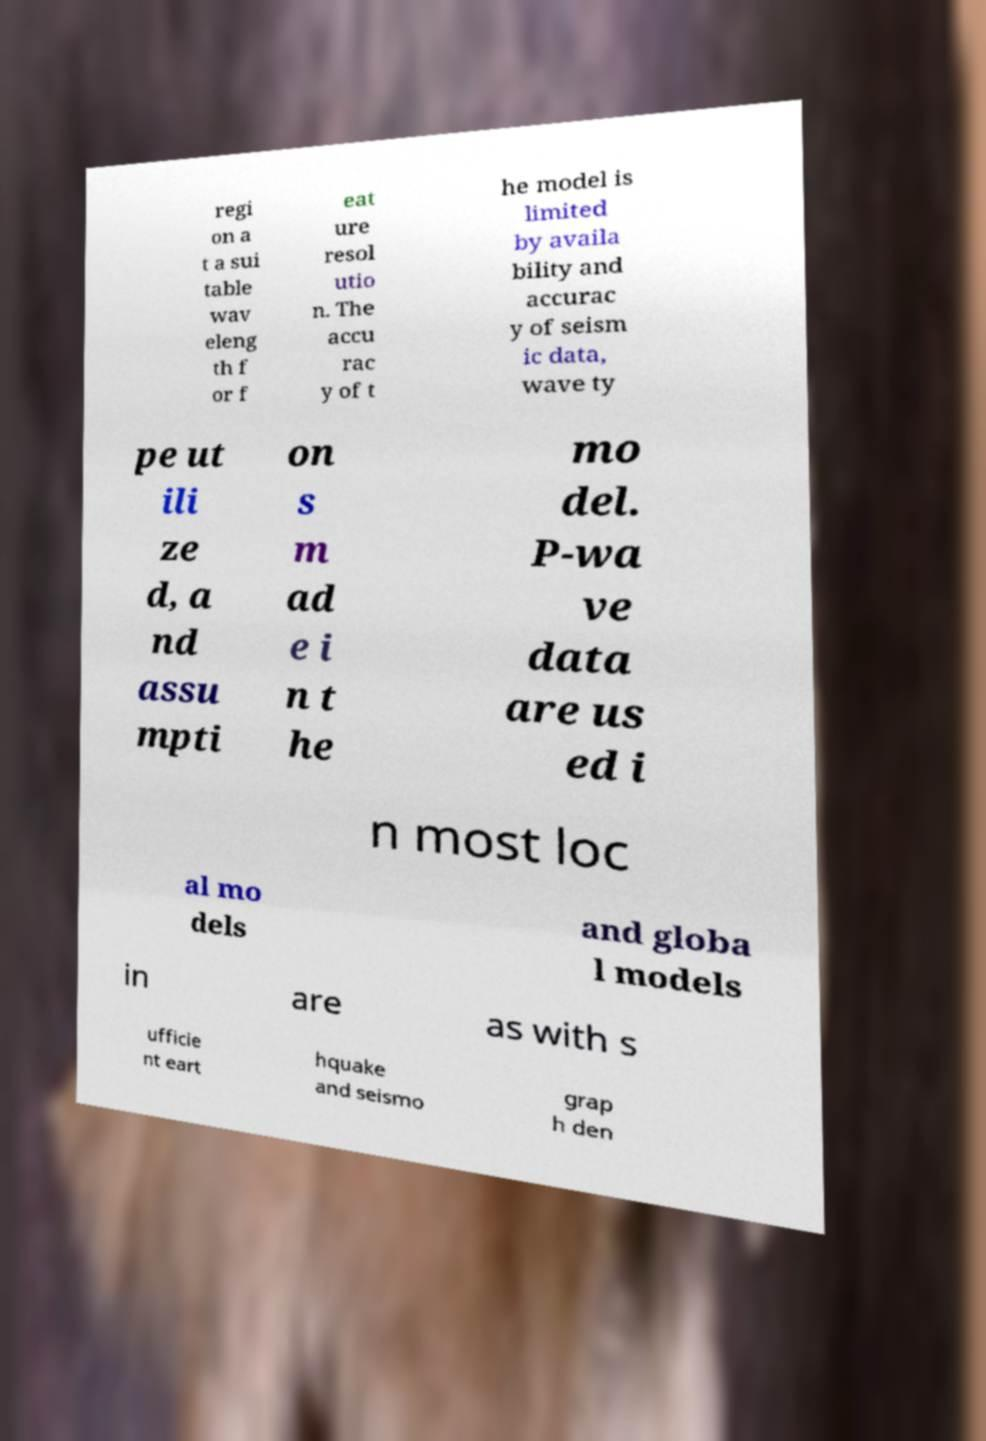I need the written content from this picture converted into text. Can you do that? regi on a t a sui table wav eleng th f or f eat ure resol utio n. The accu rac y of t he model is limited by availa bility and accurac y of seism ic data, wave ty pe ut ili ze d, a nd assu mpti on s m ad e i n t he mo del. P-wa ve data are us ed i n most loc al mo dels and globa l models in are as with s ufficie nt eart hquake and seismo grap h den 